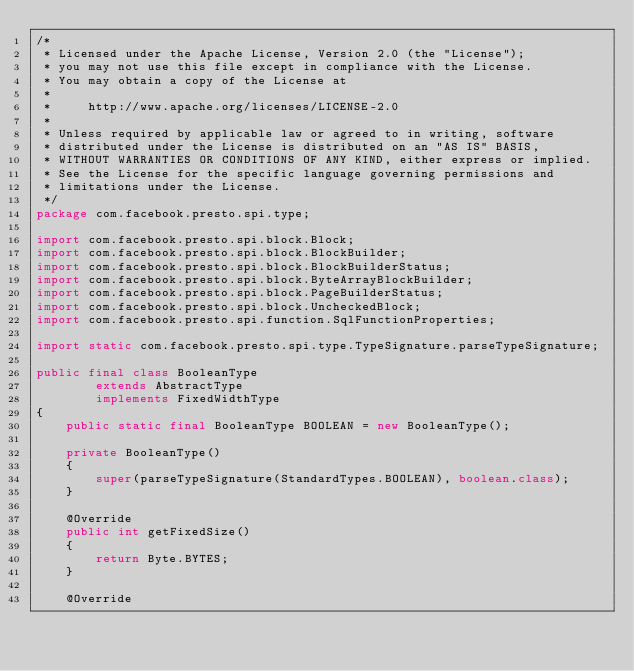<code> <loc_0><loc_0><loc_500><loc_500><_Java_>/*
 * Licensed under the Apache License, Version 2.0 (the "License");
 * you may not use this file except in compliance with the License.
 * You may obtain a copy of the License at
 *
 *     http://www.apache.org/licenses/LICENSE-2.0
 *
 * Unless required by applicable law or agreed to in writing, software
 * distributed under the License is distributed on an "AS IS" BASIS,
 * WITHOUT WARRANTIES OR CONDITIONS OF ANY KIND, either express or implied.
 * See the License for the specific language governing permissions and
 * limitations under the License.
 */
package com.facebook.presto.spi.type;

import com.facebook.presto.spi.block.Block;
import com.facebook.presto.spi.block.BlockBuilder;
import com.facebook.presto.spi.block.BlockBuilderStatus;
import com.facebook.presto.spi.block.ByteArrayBlockBuilder;
import com.facebook.presto.spi.block.PageBuilderStatus;
import com.facebook.presto.spi.block.UncheckedBlock;
import com.facebook.presto.spi.function.SqlFunctionProperties;

import static com.facebook.presto.spi.type.TypeSignature.parseTypeSignature;

public final class BooleanType
        extends AbstractType
        implements FixedWidthType
{
    public static final BooleanType BOOLEAN = new BooleanType();

    private BooleanType()
    {
        super(parseTypeSignature(StandardTypes.BOOLEAN), boolean.class);
    }

    @Override
    public int getFixedSize()
    {
        return Byte.BYTES;
    }

    @Override</code> 